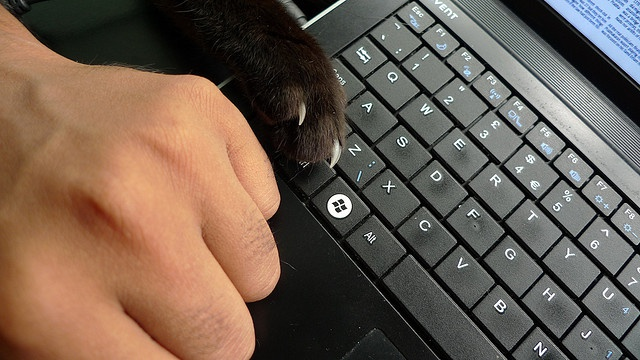Describe the objects in this image and their specific colors. I can see keyboard in black, gray, darkgray, and lightgray tones, people in black, tan, gray, and brown tones, and cat in black, maroon, and gray tones in this image. 